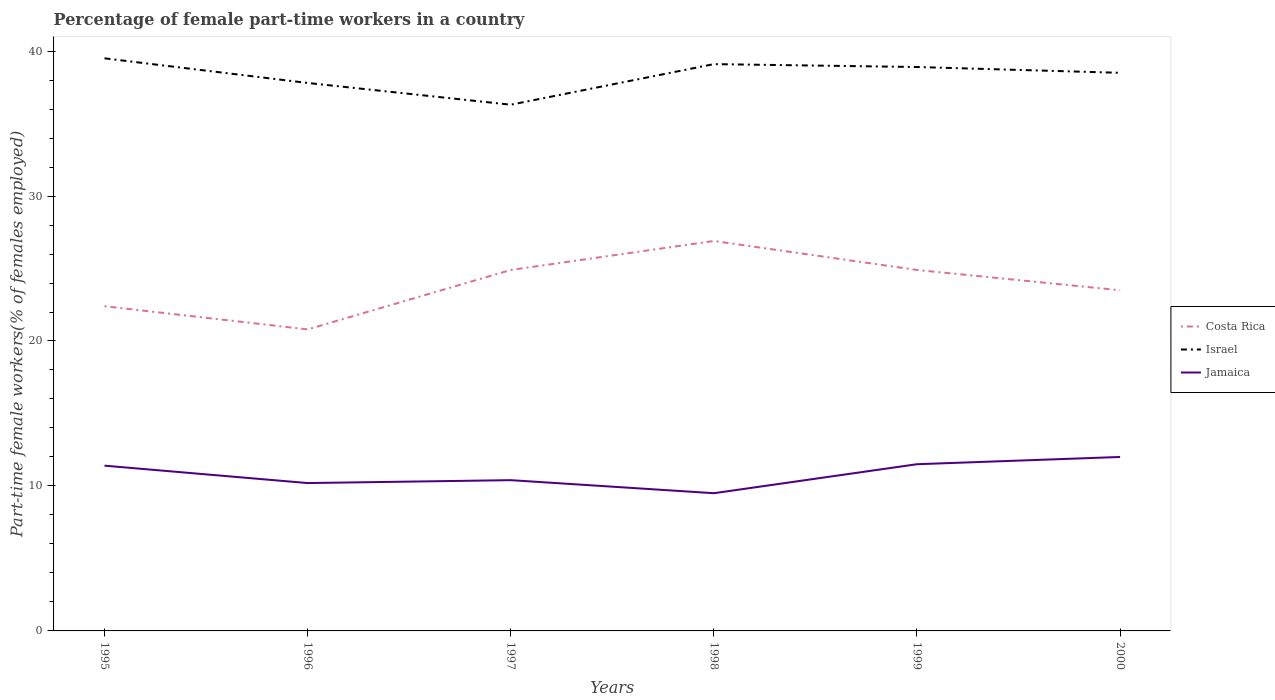How many different coloured lines are there?
Make the answer very short. 3. Is the number of lines equal to the number of legend labels?
Keep it short and to the point. Yes. Across all years, what is the maximum percentage of female part-time workers in Jamaica?
Provide a short and direct response. 9.5. What is the total percentage of female part-time workers in Costa Rica in the graph?
Offer a very short reply. -6.1. What is the difference between the highest and the second highest percentage of female part-time workers in Israel?
Provide a succinct answer. 3.2. How many years are there in the graph?
Your answer should be very brief. 6. What is the difference between two consecutive major ticks on the Y-axis?
Your answer should be compact. 10. Are the values on the major ticks of Y-axis written in scientific E-notation?
Give a very brief answer. No. How are the legend labels stacked?
Offer a terse response. Vertical. What is the title of the graph?
Your response must be concise. Percentage of female part-time workers in a country. Does "Tunisia" appear as one of the legend labels in the graph?
Provide a short and direct response. No. What is the label or title of the X-axis?
Give a very brief answer. Years. What is the label or title of the Y-axis?
Provide a short and direct response. Part-time female workers(% of females employed). What is the Part-time female workers(% of females employed) in Costa Rica in 1995?
Give a very brief answer. 22.4. What is the Part-time female workers(% of females employed) of Israel in 1995?
Make the answer very short. 39.5. What is the Part-time female workers(% of females employed) in Jamaica in 1995?
Your response must be concise. 11.4. What is the Part-time female workers(% of females employed) of Costa Rica in 1996?
Your response must be concise. 20.8. What is the Part-time female workers(% of females employed) of Israel in 1996?
Give a very brief answer. 37.8. What is the Part-time female workers(% of females employed) in Jamaica in 1996?
Your response must be concise. 10.2. What is the Part-time female workers(% of females employed) in Costa Rica in 1997?
Your answer should be compact. 24.9. What is the Part-time female workers(% of females employed) in Israel in 1997?
Your answer should be compact. 36.3. What is the Part-time female workers(% of females employed) in Jamaica in 1997?
Offer a terse response. 10.4. What is the Part-time female workers(% of females employed) in Costa Rica in 1998?
Keep it short and to the point. 26.9. What is the Part-time female workers(% of females employed) in Israel in 1998?
Ensure brevity in your answer.  39.1. What is the Part-time female workers(% of females employed) in Costa Rica in 1999?
Provide a short and direct response. 24.9. What is the Part-time female workers(% of females employed) in Israel in 1999?
Your response must be concise. 38.9. What is the Part-time female workers(% of females employed) in Costa Rica in 2000?
Your answer should be compact. 23.5. What is the Part-time female workers(% of females employed) of Israel in 2000?
Ensure brevity in your answer.  38.5. What is the Part-time female workers(% of females employed) of Jamaica in 2000?
Give a very brief answer. 12. Across all years, what is the maximum Part-time female workers(% of females employed) of Costa Rica?
Provide a succinct answer. 26.9. Across all years, what is the maximum Part-time female workers(% of females employed) of Israel?
Provide a short and direct response. 39.5. Across all years, what is the maximum Part-time female workers(% of females employed) of Jamaica?
Your answer should be very brief. 12. Across all years, what is the minimum Part-time female workers(% of females employed) in Costa Rica?
Make the answer very short. 20.8. Across all years, what is the minimum Part-time female workers(% of females employed) of Israel?
Offer a terse response. 36.3. What is the total Part-time female workers(% of females employed) in Costa Rica in the graph?
Offer a terse response. 143.4. What is the total Part-time female workers(% of females employed) in Israel in the graph?
Make the answer very short. 230.1. What is the total Part-time female workers(% of females employed) of Jamaica in the graph?
Offer a very short reply. 65. What is the difference between the Part-time female workers(% of females employed) of Costa Rica in 1995 and that in 1996?
Provide a succinct answer. 1.6. What is the difference between the Part-time female workers(% of females employed) of Israel in 1995 and that in 1997?
Give a very brief answer. 3.2. What is the difference between the Part-time female workers(% of females employed) in Jamaica in 1995 and that in 1997?
Provide a short and direct response. 1. What is the difference between the Part-time female workers(% of females employed) in Israel in 1995 and that in 1999?
Give a very brief answer. 0.6. What is the difference between the Part-time female workers(% of females employed) in Jamaica in 1995 and that in 1999?
Your response must be concise. -0.1. What is the difference between the Part-time female workers(% of females employed) in Costa Rica in 1996 and that in 1997?
Your response must be concise. -4.1. What is the difference between the Part-time female workers(% of females employed) in Jamaica in 1996 and that in 1997?
Your response must be concise. -0.2. What is the difference between the Part-time female workers(% of females employed) in Israel in 1996 and that in 1998?
Make the answer very short. -1.3. What is the difference between the Part-time female workers(% of females employed) of Jamaica in 1996 and that in 1998?
Provide a succinct answer. 0.7. What is the difference between the Part-time female workers(% of females employed) in Costa Rica in 1996 and that in 1999?
Offer a terse response. -4.1. What is the difference between the Part-time female workers(% of females employed) of Jamaica in 1996 and that in 1999?
Your answer should be very brief. -1.3. What is the difference between the Part-time female workers(% of females employed) of Israel in 1996 and that in 2000?
Keep it short and to the point. -0.7. What is the difference between the Part-time female workers(% of females employed) in Costa Rica in 1997 and that in 1999?
Ensure brevity in your answer.  0. What is the difference between the Part-time female workers(% of females employed) in Jamaica in 1997 and that in 1999?
Make the answer very short. -1.1. What is the difference between the Part-time female workers(% of females employed) of Costa Rica in 1997 and that in 2000?
Your answer should be compact. 1.4. What is the difference between the Part-time female workers(% of females employed) in Jamaica in 1997 and that in 2000?
Your answer should be very brief. -1.6. What is the difference between the Part-time female workers(% of females employed) in Israel in 1998 and that in 1999?
Provide a succinct answer. 0.2. What is the difference between the Part-time female workers(% of females employed) in Jamaica in 1998 and that in 1999?
Your answer should be very brief. -2. What is the difference between the Part-time female workers(% of females employed) in Israel in 1998 and that in 2000?
Offer a very short reply. 0.6. What is the difference between the Part-time female workers(% of females employed) in Jamaica in 1998 and that in 2000?
Ensure brevity in your answer.  -2.5. What is the difference between the Part-time female workers(% of females employed) of Jamaica in 1999 and that in 2000?
Your answer should be compact. -0.5. What is the difference between the Part-time female workers(% of females employed) of Costa Rica in 1995 and the Part-time female workers(% of females employed) of Israel in 1996?
Your answer should be very brief. -15.4. What is the difference between the Part-time female workers(% of females employed) in Israel in 1995 and the Part-time female workers(% of females employed) in Jamaica in 1996?
Offer a very short reply. 29.3. What is the difference between the Part-time female workers(% of females employed) of Israel in 1995 and the Part-time female workers(% of females employed) of Jamaica in 1997?
Provide a succinct answer. 29.1. What is the difference between the Part-time female workers(% of females employed) in Costa Rica in 1995 and the Part-time female workers(% of females employed) in Israel in 1998?
Provide a succinct answer. -16.7. What is the difference between the Part-time female workers(% of females employed) in Costa Rica in 1995 and the Part-time female workers(% of females employed) in Israel in 1999?
Make the answer very short. -16.5. What is the difference between the Part-time female workers(% of females employed) of Israel in 1995 and the Part-time female workers(% of females employed) of Jamaica in 1999?
Give a very brief answer. 28. What is the difference between the Part-time female workers(% of females employed) in Costa Rica in 1995 and the Part-time female workers(% of females employed) in Israel in 2000?
Give a very brief answer. -16.1. What is the difference between the Part-time female workers(% of females employed) in Israel in 1995 and the Part-time female workers(% of females employed) in Jamaica in 2000?
Offer a very short reply. 27.5. What is the difference between the Part-time female workers(% of females employed) in Costa Rica in 1996 and the Part-time female workers(% of females employed) in Israel in 1997?
Offer a terse response. -15.5. What is the difference between the Part-time female workers(% of females employed) in Costa Rica in 1996 and the Part-time female workers(% of females employed) in Jamaica in 1997?
Ensure brevity in your answer.  10.4. What is the difference between the Part-time female workers(% of females employed) of Israel in 1996 and the Part-time female workers(% of females employed) of Jamaica in 1997?
Offer a terse response. 27.4. What is the difference between the Part-time female workers(% of females employed) of Costa Rica in 1996 and the Part-time female workers(% of females employed) of Israel in 1998?
Your answer should be very brief. -18.3. What is the difference between the Part-time female workers(% of females employed) in Israel in 1996 and the Part-time female workers(% of females employed) in Jamaica in 1998?
Your answer should be very brief. 28.3. What is the difference between the Part-time female workers(% of females employed) of Costa Rica in 1996 and the Part-time female workers(% of females employed) of Israel in 1999?
Your answer should be very brief. -18.1. What is the difference between the Part-time female workers(% of females employed) of Israel in 1996 and the Part-time female workers(% of females employed) of Jamaica in 1999?
Your answer should be very brief. 26.3. What is the difference between the Part-time female workers(% of females employed) in Costa Rica in 1996 and the Part-time female workers(% of females employed) in Israel in 2000?
Offer a very short reply. -17.7. What is the difference between the Part-time female workers(% of females employed) of Israel in 1996 and the Part-time female workers(% of females employed) of Jamaica in 2000?
Offer a terse response. 25.8. What is the difference between the Part-time female workers(% of females employed) in Costa Rica in 1997 and the Part-time female workers(% of females employed) in Israel in 1998?
Your answer should be very brief. -14.2. What is the difference between the Part-time female workers(% of females employed) in Costa Rica in 1997 and the Part-time female workers(% of females employed) in Jamaica in 1998?
Your answer should be very brief. 15.4. What is the difference between the Part-time female workers(% of females employed) of Israel in 1997 and the Part-time female workers(% of females employed) of Jamaica in 1998?
Your response must be concise. 26.8. What is the difference between the Part-time female workers(% of females employed) in Costa Rica in 1997 and the Part-time female workers(% of females employed) in Jamaica in 1999?
Your answer should be very brief. 13.4. What is the difference between the Part-time female workers(% of females employed) in Israel in 1997 and the Part-time female workers(% of females employed) in Jamaica in 1999?
Ensure brevity in your answer.  24.8. What is the difference between the Part-time female workers(% of females employed) in Costa Rica in 1997 and the Part-time female workers(% of females employed) in Israel in 2000?
Provide a short and direct response. -13.6. What is the difference between the Part-time female workers(% of females employed) of Costa Rica in 1997 and the Part-time female workers(% of females employed) of Jamaica in 2000?
Provide a short and direct response. 12.9. What is the difference between the Part-time female workers(% of females employed) of Israel in 1997 and the Part-time female workers(% of females employed) of Jamaica in 2000?
Offer a very short reply. 24.3. What is the difference between the Part-time female workers(% of females employed) in Israel in 1998 and the Part-time female workers(% of females employed) in Jamaica in 1999?
Make the answer very short. 27.6. What is the difference between the Part-time female workers(% of females employed) of Costa Rica in 1998 and the Part-time female workers(% of females employed) of Israel in 2000?
Your response must be concise. -11.6. What is the difference between the Part-time female workers(% of females employed) of Costa Rica in 1998 and the Part-time female workers(% of females employed) of Jamaica in 2000?
Provide a succinct answer. 14.9. What is the difference between the Part-time female workers(% of females employed) of Israel in 1998 and the Part-time female workers(% of females employed) of Jamaica in 2000?
Your answer should be very brief. 27.1. What is the difference between the Part-time female workers(% of females employed) in Costa Rica in 1999 and the Part-time female workers(% of females employed) in Israel in 2000?
Your answer should be compact. -13.6. What is the difference between the Part-time female workers(% of females employed) in Costa Rica in 1999 and the Part-time female workers(% of females employed) in Jamaica in 2000?
Keep it short and to the point. 12.9. What is the difference between the Part-time female workers(% of females employed) in Israel in 1999 and the Part-time female workers(% of females employed) in Jamaica in 2000?
Provide a succinct answer. 26.9. What is the average Part-time female workers(% of females employed) of Costa Rica per year?
Make the answer very short. 23.9. What is the average Part-time female workers(% of females employed) in Israel per year?
Keep it short and to the point. 38.35. What is the average Part-time female workers(% of females employed) of Jamaica per year?
Offer a very short reply. 10.83. In the year 1995, what is the difference between the Part-time female workers(% of females employed) in Costa Rica and Part-time female workers(% of females employed) in Israel?
Your response must be concise. -17.1. In the year 1995, what is the difference between the Part-time female workers(% of females employed) in Israel and Part-time female workers(% of females employed) in Jamaica?
Offer a terse response. 28.1. In the year 1996, what is the difference between the Part-time female workers(% of females employed) of Costa Rica and Part-time female workers(% of females employed) of Israel?
Provide a succinct answer. -17. In the year 1996, what is the difference between the Part-time female workers(% of females employed) of Israel and Part-time female workers(% of females employed) of Jamaica?
Ensure brevity in your answer.  27.6. In the year 1997, what is the difference between the Part-time female workers(% of females employed) in Costa Rica and Part-time female workers(% of females employed) in Jamaica?
Your answer should be compact. 14.5. In the year 1997, what is the difference between the Part-time female workers(% of females employed) of Israel and Part-time female workers(% of females employed) of Jamaica?
Offer a very short reply. 25.9. In the year 1998, what is the difference between the Part-time female workers(% of females employed) of Costa Rica and Part-time female workers(% of females employed) of Israel?
Your answer should be compact. -12.2. In the year 1998, what is the difference between the Part-time female workers(% of females employed) in Israel and Part-time female workers(% of females employed) in Jamaica?
Offer a terse response. 29.6. In the year 1999, what is the difference between the Part-time female workers(% of females employed) of Costa Rica and Part-time female workers(% of females employed) of Israel?
Provide a short and direct response. -14. In the year 1999, what is the difference between the Part-time female workers(% of females employed) of Israel and Part-time female workers(% of females employed) of Jamaica?
Ensure brevity in your answer.  27.4. In the year 2000, what is the difference between the Part-time female workers(% of females employed) in Israel and Part-time female workers(% of females employed) in Jamaica?
Provide a short and direct response. 26.5. What is the ratio of the Part-time female workers(% of females employed) of Israel in 1995 to that in 1996?
Give a very brief answer. 1.04. What is the ratio of the Part-time female workers(% of females employed) of Jamaica in 1995 to that in 1996?
Your answer should be very brief. 1.12. What is the ratio of the Part-time female workers(% of females employed) of Costa Rica in 1995 to that in 1997?
Your answer should be very brief. 0.9. What is the ratio of the Part-time female workers(% of females employed) of Israel in 1995 to that in 1997?
Give a very brief answer. 1.09. What is the ratio of the Part-time female workers(% of females employed) in Jamaica in 1995 to that in 1997?
Your answer should be compact. 1.1. What is the ratio of the Part-time female workers(% of females employed) of Costa Rica in 1995 to that in 1998?
Offer a terse response. 0.83. What is the ratio of the Part-time female workers(% of females employed) of Israel in 1995 to that in 1998?
Offer a very short reply. 1.01. What is the ratio of the Part-time female workers(% of females employed) in Costa Rica in 1995 to that in 1999?
Ensure brevity in your answer.  0.9. What is the ratio of the Part-time female workers(% of females employed) in Israel in 1995 to that in 1999?
Give a very brief answer. 1.02. What is the ratio of the Part-time female workers(% of females employed) of Jamaica in 1995 to that in 1999?
Make the answer very short. 0.99. What is the ratio of the Part-time female workers(% of females employed) of Costa Rica in 1995 to that in 2000?
Make the answer very short. 0.95. What is the ratio of the Part-time female workers(% of females employed) in Israel in 1995 to that in 2000?
Provide a short and direct response. 1.03. What is the ratio of the Part-time female workers(% of females employed) in Jamaica in 1995 to that in 2000?
Your answer should be very brief. 0.95. What is the ratio of the Part-time female workers(% of females employed) in Costa Rica in 1996 to that in 1997?
Make the answer very short. 0.84. What is the ratio of the Part-time female workers(% of females employed) in Israel in 1996 to that in 1997?
Make the answer very short. 1.04. What is the ratio of the Part-time female workers(% of females employed) of Jamaica in 1996 to that in 1997?
Keep it short and to the point. 0.98. What is the ratio of the Part-time female workers(% of females employed) of Costa Rica in 1996 to that in 1998?
Make the answer very short. 0.77. What is the ratio of the Part-time female workers(% of females employed) in Israel in 1996 to that in 1998?
Give a very brief answer. 0.97. What is the ratio of the Part-time female workers(% of females employed) of Jamaica in 1996 to that in 1998?
Provide a short and direct response. 1.07. What is the ratio of the Part-time female workers(% of females employed) of Costa Rica in 1996 to that in 1999?
Provide a short and direct response. 0.84. What is the ratio of the Part-time female workers(% of females employed) in Israel in 1996 to that in 1999?
Provide a short and direct response. 0.97. What is the ratio of the Part-time female workers(% of females employed) of Jamaica in 1996 to that in 1999?
Your answer should be very brief. 0.89. What is the ratio of the Part-time female workers(% of females employed) of Costa Rica in 1996 to that in 2000?
Keep it short and to the point. 0.89. What is the ratio of the Part-time female workers(% of females employed) in Israel in 1996 to that in 2000?
Your answer should be very brief. 0.98. What is the ratio of the Part-time female workers(% of females employed) of Costa Rica in 1997 to that in 1998?
Ensure brevity in your answer.  0.93. What is the ratio of the Part-time female workers(% of females employed) in Israel in 1997 to that in 1998?
Ensure brevity in your answer.  0.93. What is the ratio of the Part-time female workers(% of females employed) of Jamaica in 1997 to that in 1998?
Provide a short and direct response. 1.09. What is the ratio of the Part-time female workers(% of females employed) of Costa Rica in 1997 to that in 1999?
Ensure brevity in your answer.  1. What is the ratio of the Part-time female workers(% of females employed) of Israel in 1997 to that in 1999?
Make the answer very short. 0.93. What is the ratio of the Part-time female workers(% of females employed) in Jamaica in 1997 to that in 1999?
Your answer should be compact. 0.9. What is the ratio of the Part-time female workers(% of females employed) in Costa Rica in 1997 to that in 2000?
Offer a terse response. 1.06. What is the ratio of the Part-time female workers(% of females employed) of Israel in 1997 to that in 2000?
Keep it short and to the point. 0.94. What is the ratio of the Part-time female workers(% of females employed) of Jamaica in 1997 to that in 2000?
Make the answer very short. 0.87. What is the ratio of the Part-time female workers(% of females employed) of Costa Rica in 1998 to that in 1999?
Ensure brevity in your answer.  1.08. What is the ratio of the Part-time female workers(% of females employed) of Israel in 1998 to that in 1999?
Provide a succinct answer. 1.01. What is the ratio of the Part-time female workers(% of females employed) in Jamaica in 1998 to that in 1999?
Provide a short and direct response. 0.83. What is the ratio of the Part-time female workers(% of females employed) of Costa Rica in 1998 to that in 2000?
Give a very brief answer. 1.14. What is the ratio of the Part-time female workers(% of females employed) of Israel in 1998 to that in 2000?
Your answer should be compact. 1.02. What is the ratio of the Part-time female workers(% of females employed) in Jamaica in 1998 to that in 2000?
Make the answer very short. 0.79. What is the ratio of the Part-time female workers(% of females employed) of Costa Rica in 1999 to that in 2000?
Your answer should be compact. 1.06. What is the ratio of the Part-time female workers(% of females employed) in Israel in 1999 to that in 2000?
Ensure brevity in your answer.  1.01. What is the ratio of the Part-time female workers(% of females employed) in Jamaica in 1999 to that in 2000?
Your answer should be very brief. 0.96. What is the difference between the highest and the second highest Part-time female workers(% of females employed) in Israel?
Ensure brevity in your answer.  0.4. What is the difference between the highest and the lowest Part-time female workers(% of females employed) of Costa Rica?
Provide a succinct answer. 6.1. What is the difference between the highest and the lowest Part-time female workers(% of females employed) in Jamaica?
Offer a terse response. 2.5. 